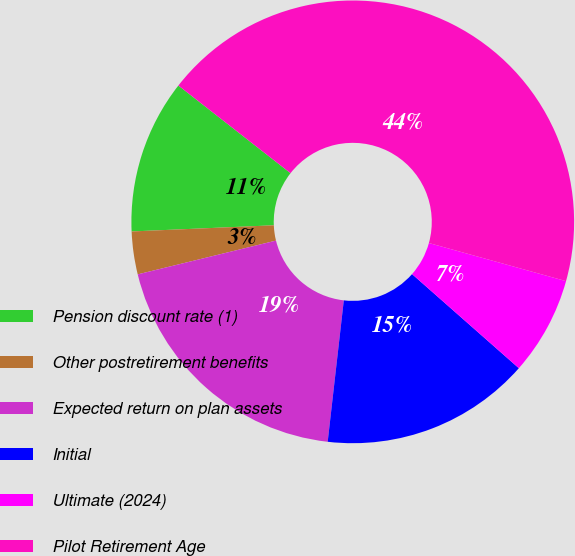Convert chart. <chart><loc_0><loc_0><loc_500><loc_500><pie_chart><fcel>Pension discount rate (1)<fcel>Other postretirement benefits<fcel>Expected return on plan assets<fcel>Initial<fcel>Ultimate (2024)<fcel>Pilot Retirement Age<nl><fcel>11.25%<fcel>3.12%<fcel>19.38%<fcel>15.31%<fcel>7.18%<fcel>43.75%<nl></chart> 